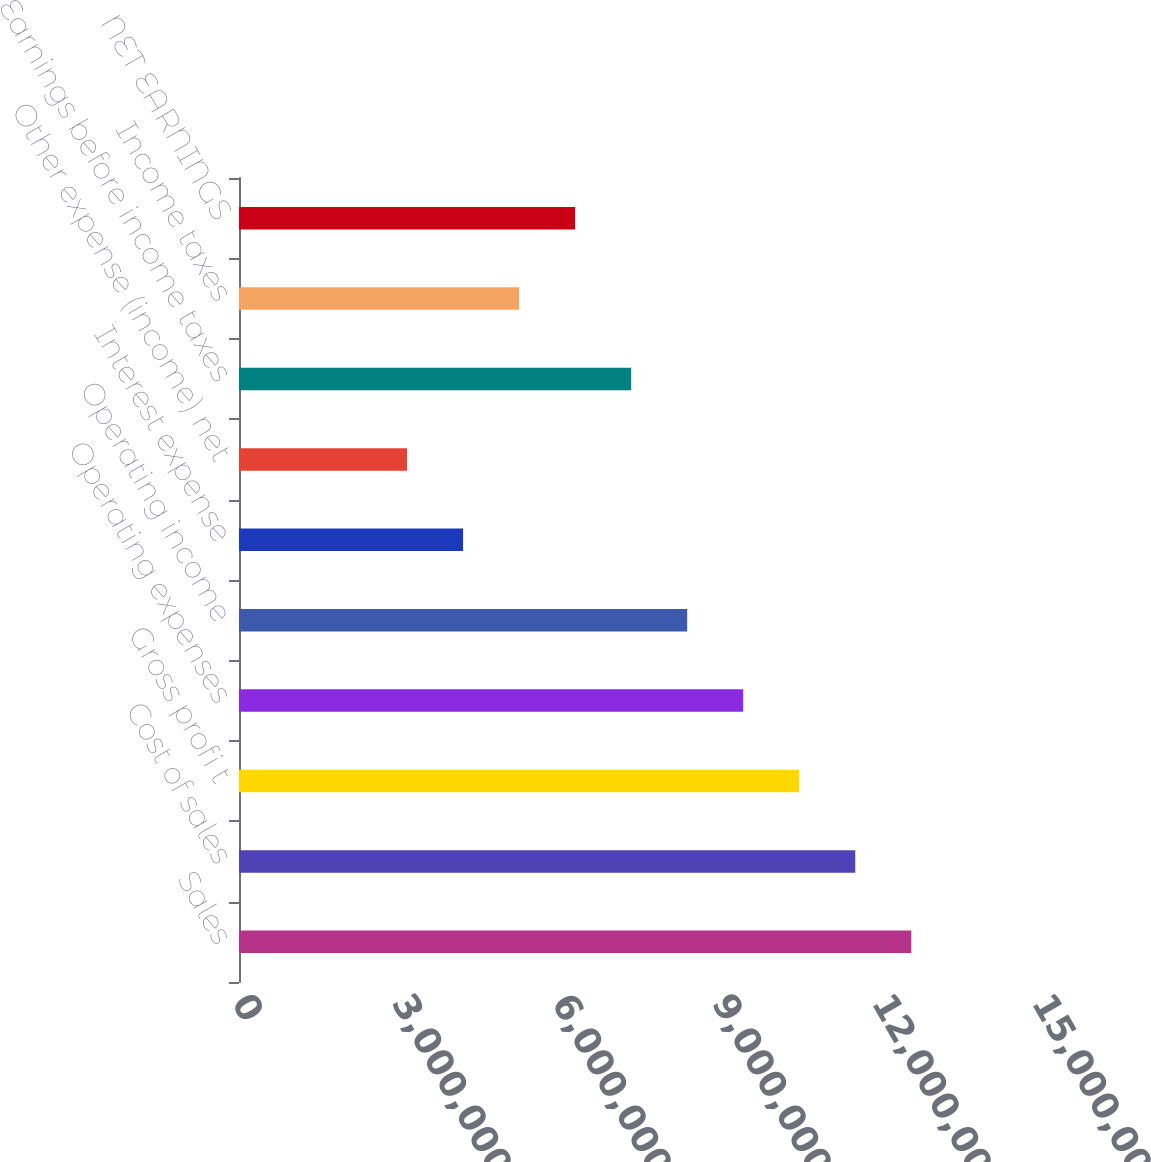<chart> <loc_0><loc_0><loc_500><loc_500><bar_chart><fcel>Sales<fcel>Cost of sales<fcel>Gross profi t<fcel>Operating expenses<fcel>Operating income<fcel>Interest expense<fcel>Other expense (income) net<fcel>Earnings before income taxes<fcel>Income taxes<fcel>NET EARNINGS<nl><fcel>1.26057e+07<fcel>1.15552e+07<fcel>1.05047e+07<fcel>9.45427e+06<fcel>8.4038e+06<fcel>4.2019e+06<fcel>3.15142e+06<fcel>7.35332e+06<fcel>5.25237e+06<fcel>6.30285e+06<nl></chart> 